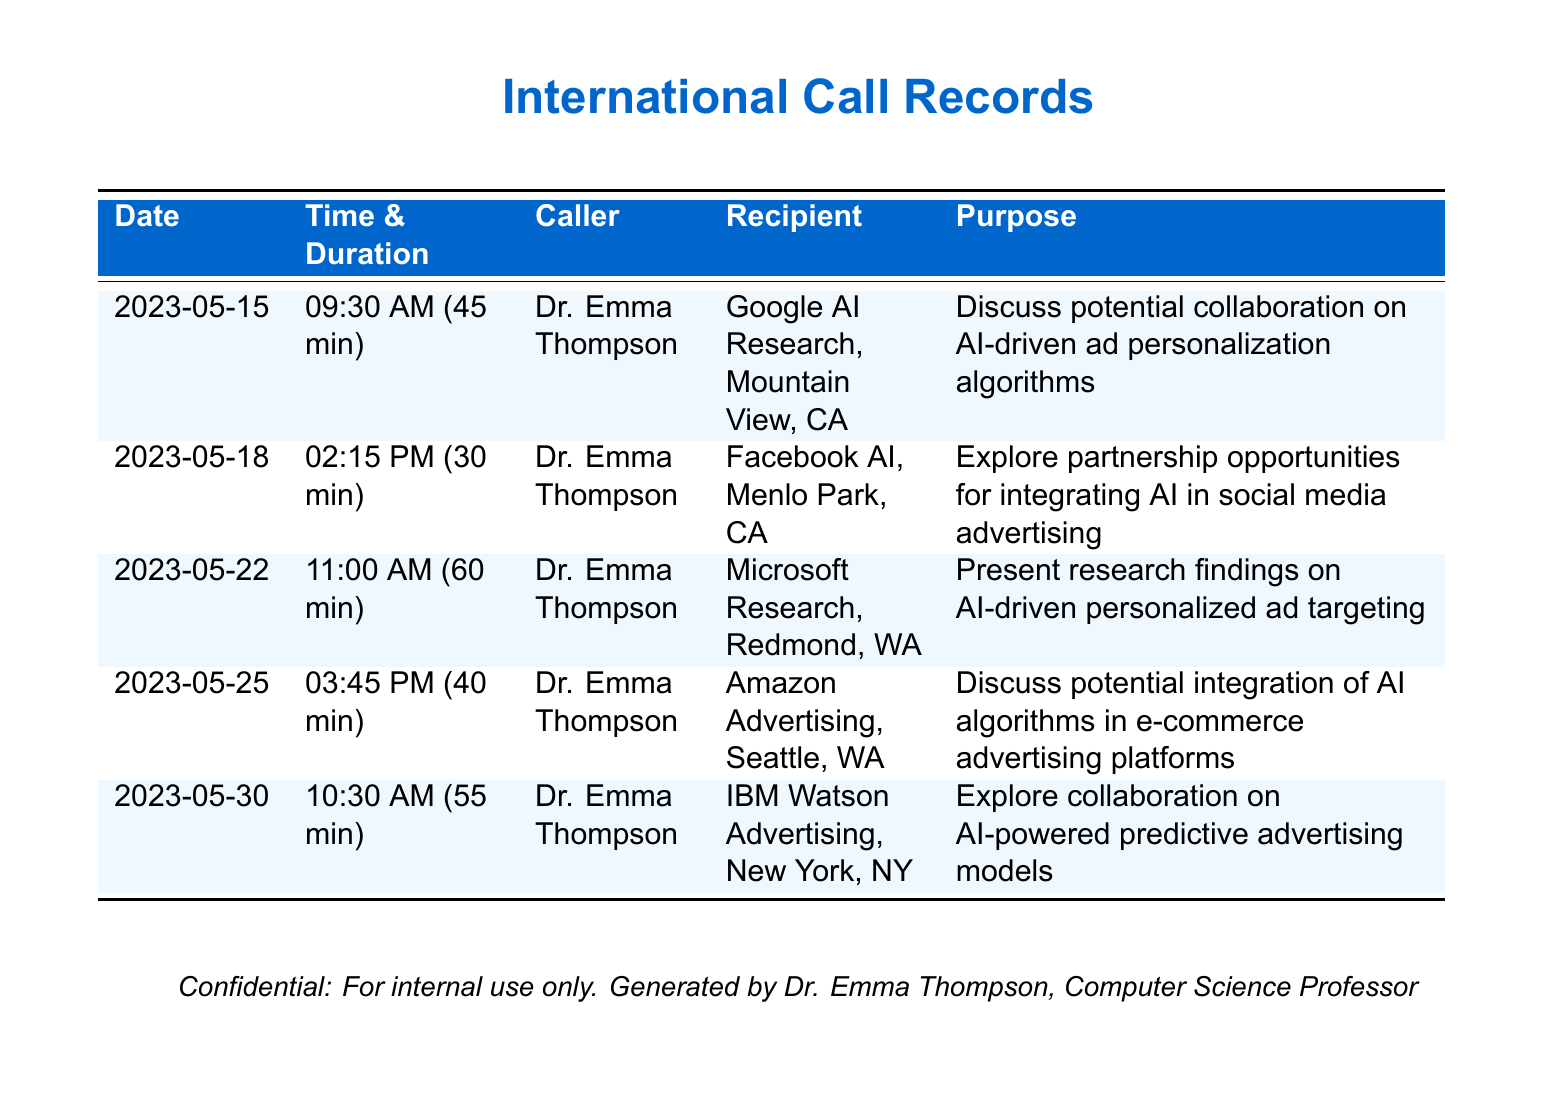What is the date of the call with Google AI Research? The call with Google AI Research took place on May 15, 2023.
Answer: May 15, 2023 Who was the caller for the call on May 22, 2023? The caller for the call on May 22, 2023, was Dr. Emma Thompson.
Answer: Dr. Emma Thompson What was the duration of the call with IBM Watson Advertising? The call with IBM Watson Advertising lasted for 55 minutes.
Answer: 55 min What is the primary purpose of the call with Amazon Advertising? The primary purpose of the call with Amazon Advertising was to discuss potential integration of AI algorithms in e-commerce advertising platforms.
Answer: Discuss potential integration of AI algorithms in e-commerce advertising platforms Which company was discussed on May 18, 2023? On May 18, 2023, the company discussed was Facebook AI.
Answer: Facebook AI What is the total number of calls recorded in this document? The document records a total of five calls made by Dr. Emma Thompson.
Answer: 5 How many minutes did the call with Microsoft Research last? The call with Microsoft Research lasted for 60 minutes.
Answer: 60 min Which company was contacted to explore collaboration on predictive advertising models? IBM Watson Advertising was contacted to explore collaboration on predictive advertising models.
Answer: IBM Watson Advertising What is the main research focus in the call on May 22, 2023? The main research focus in the call on May 22, 2023, was on AI-driven personalized ad targeting.
Answer: AI-driven personalized ad targeting 